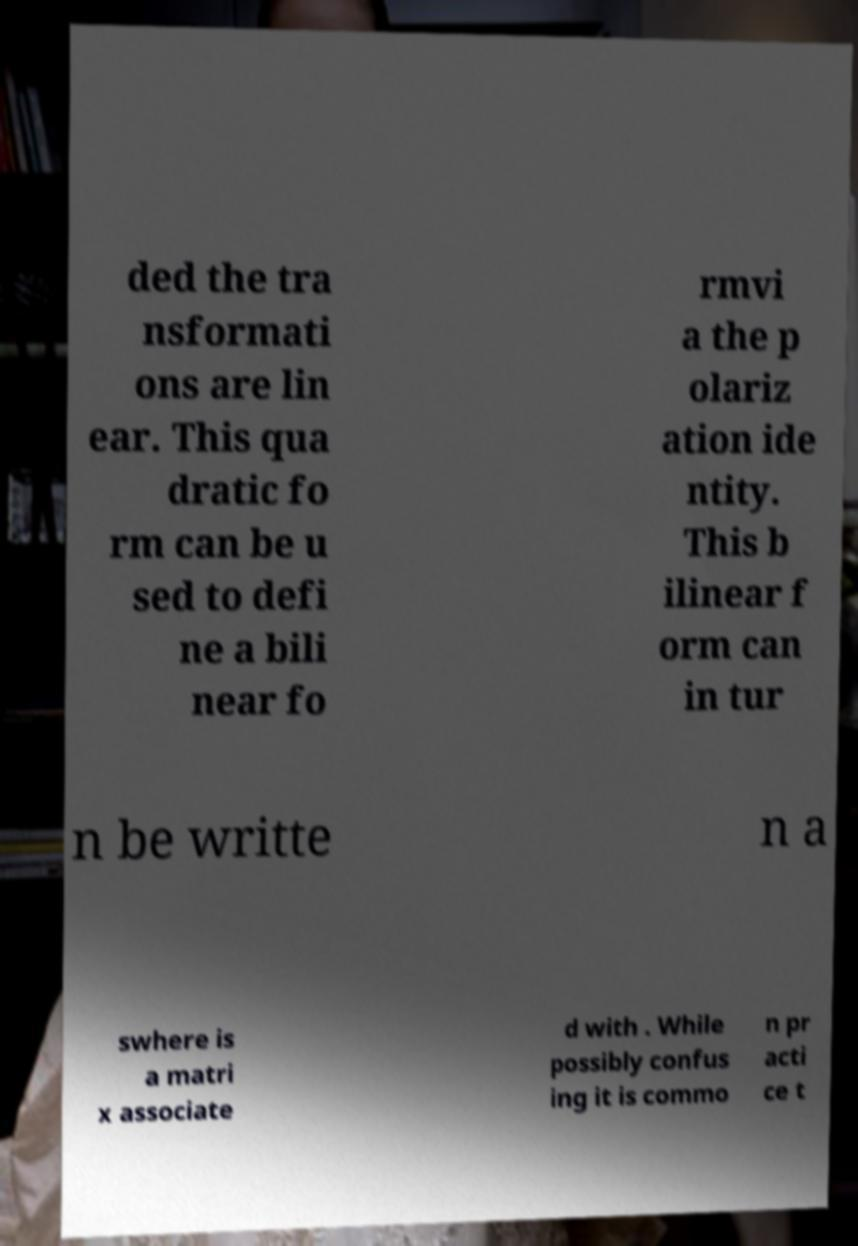For documentation purposes, I need the text within this image transcribed. Could you provide that? ded the tra nsformati ons are lin ear. This qua dratic fo rm can be u sed to defi ne a bili near fo rmvi a the p olariz ation ide ntity. This b ilinear f orm can in tur n be writte n a swhere is a matri x associate d with . While possibly confus ing it is commo n pr acti ce t 